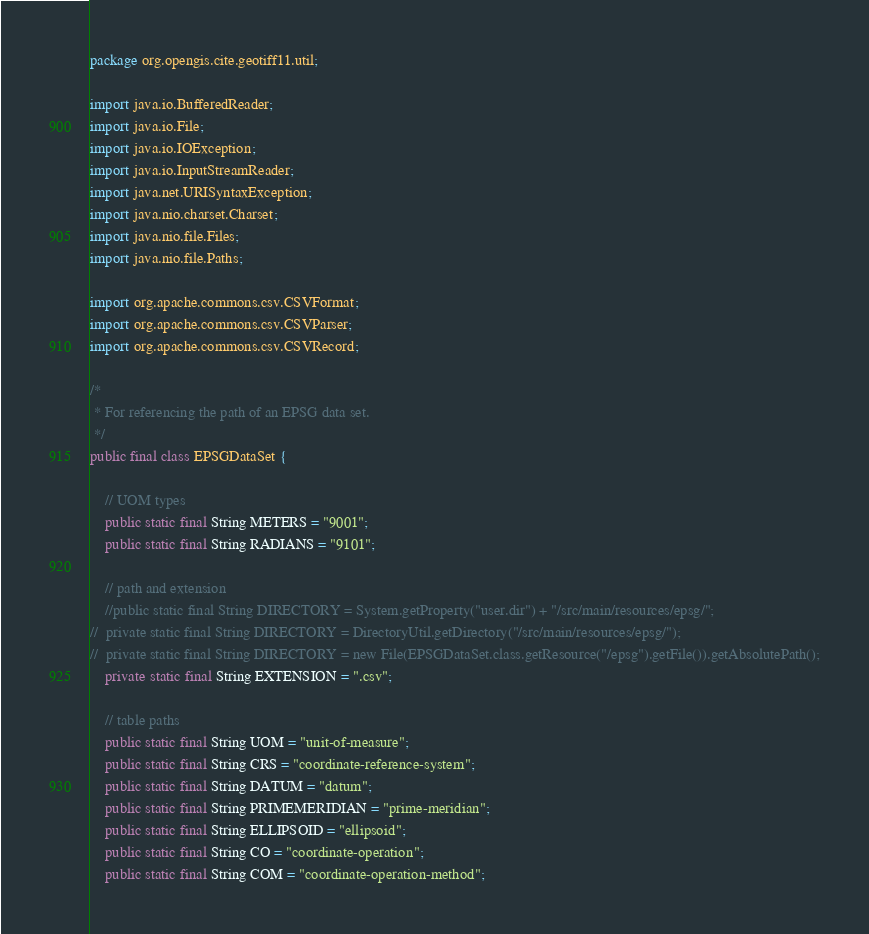<code> <loc_0><loc_0><loc_500><loc_500><_Java_>package org.opengis.cite.geotiff11.util;

import java.io.BufferedReader;
import java.io.File;
import java.io.IOException;
import java.io.InputStreamReader;
import java.net.URISyntaxException;
import java.nio.charset.Charset;
import java.nio.file.Files;
import java.nio.file.Paths;

import org.apache.commons.csv.CSVFormat;
import org.apache.commons.csv.CSVParser;
import org.apache.commons.csv.CSVRecord;

/*
 * For referencing the path of an EPSG data set.
 */
public final class EPSGDataSet {

	// UOM types
	public static final String METERS = "9001";
	public static final String RADIANS = "9101";
	
	// path and extension
	//public static final String DIRECTORY = System.getProperty("user.dir") + "/src/main/resources/epsg/";
//	private static final String DIRECTORY = DirectoryUtil.getDirectory("/src/main/resources/epsg/");
//	private static final String DIRECTORY = new File(EPSGDataSet.class.getResource("/epsg").getFile()).getAbsolutePath();
	private static final String EXTENSION = ".csv";
	
	// table paths
	public static final String UOM = "unit-of-measure";
	public static final String CRS = "coordinate-reference-system";
	public static final String DATUM = "datum";
	public static final String PRIMEMERIDIAN = "prime-meridian";
	public static final String ELLIPSOID = "ellipsoid";
	public static final String CO = "coordinate-operation";
	public static final String COM = "coordinate-operation-method";</code> 